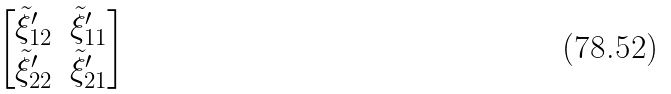<formula> <loc_0><loc_0><loc_500><loc_500>\begin{bmatrix} \tilde { \xi } ^ { \prime } _ { 1 2 } & \tilde { \xi } ^ { \prime } _ { 1 1 } \\ \tilde { \xi } ^ { \prime } _ { 2 2 } & \tilde { \xi } ^ { \prime } _ { 2 1 } \end{bmatrix}</formula> 